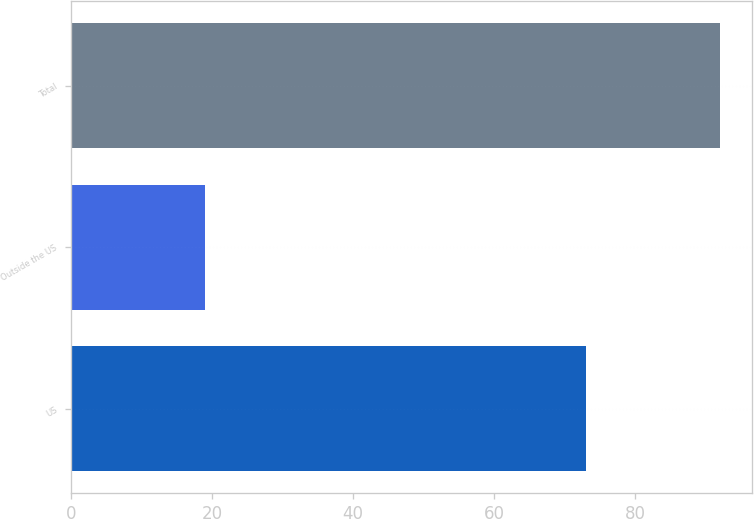Convert chart. <chart><loc_0><loc_0><loc_500><loc_500><bar_chart><fcel>US<fcel>Outside the US<fcel>Total<nl><fcel>73<fcel>19<fcel>92<nl></chart> 